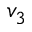<formula> <loc_0><loc_0><loc_500><loc_500>v _ { 3 }</formula> 